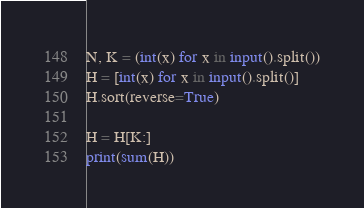<code> <loc_0><loc_0><loc_500><loc_500><_Python_>N, K = (int(x) for x in input().split())
H = [int(x) for x in input().split()]
H.sort(reverse=True)

H = H[K:]
print(sum(H))</code> 